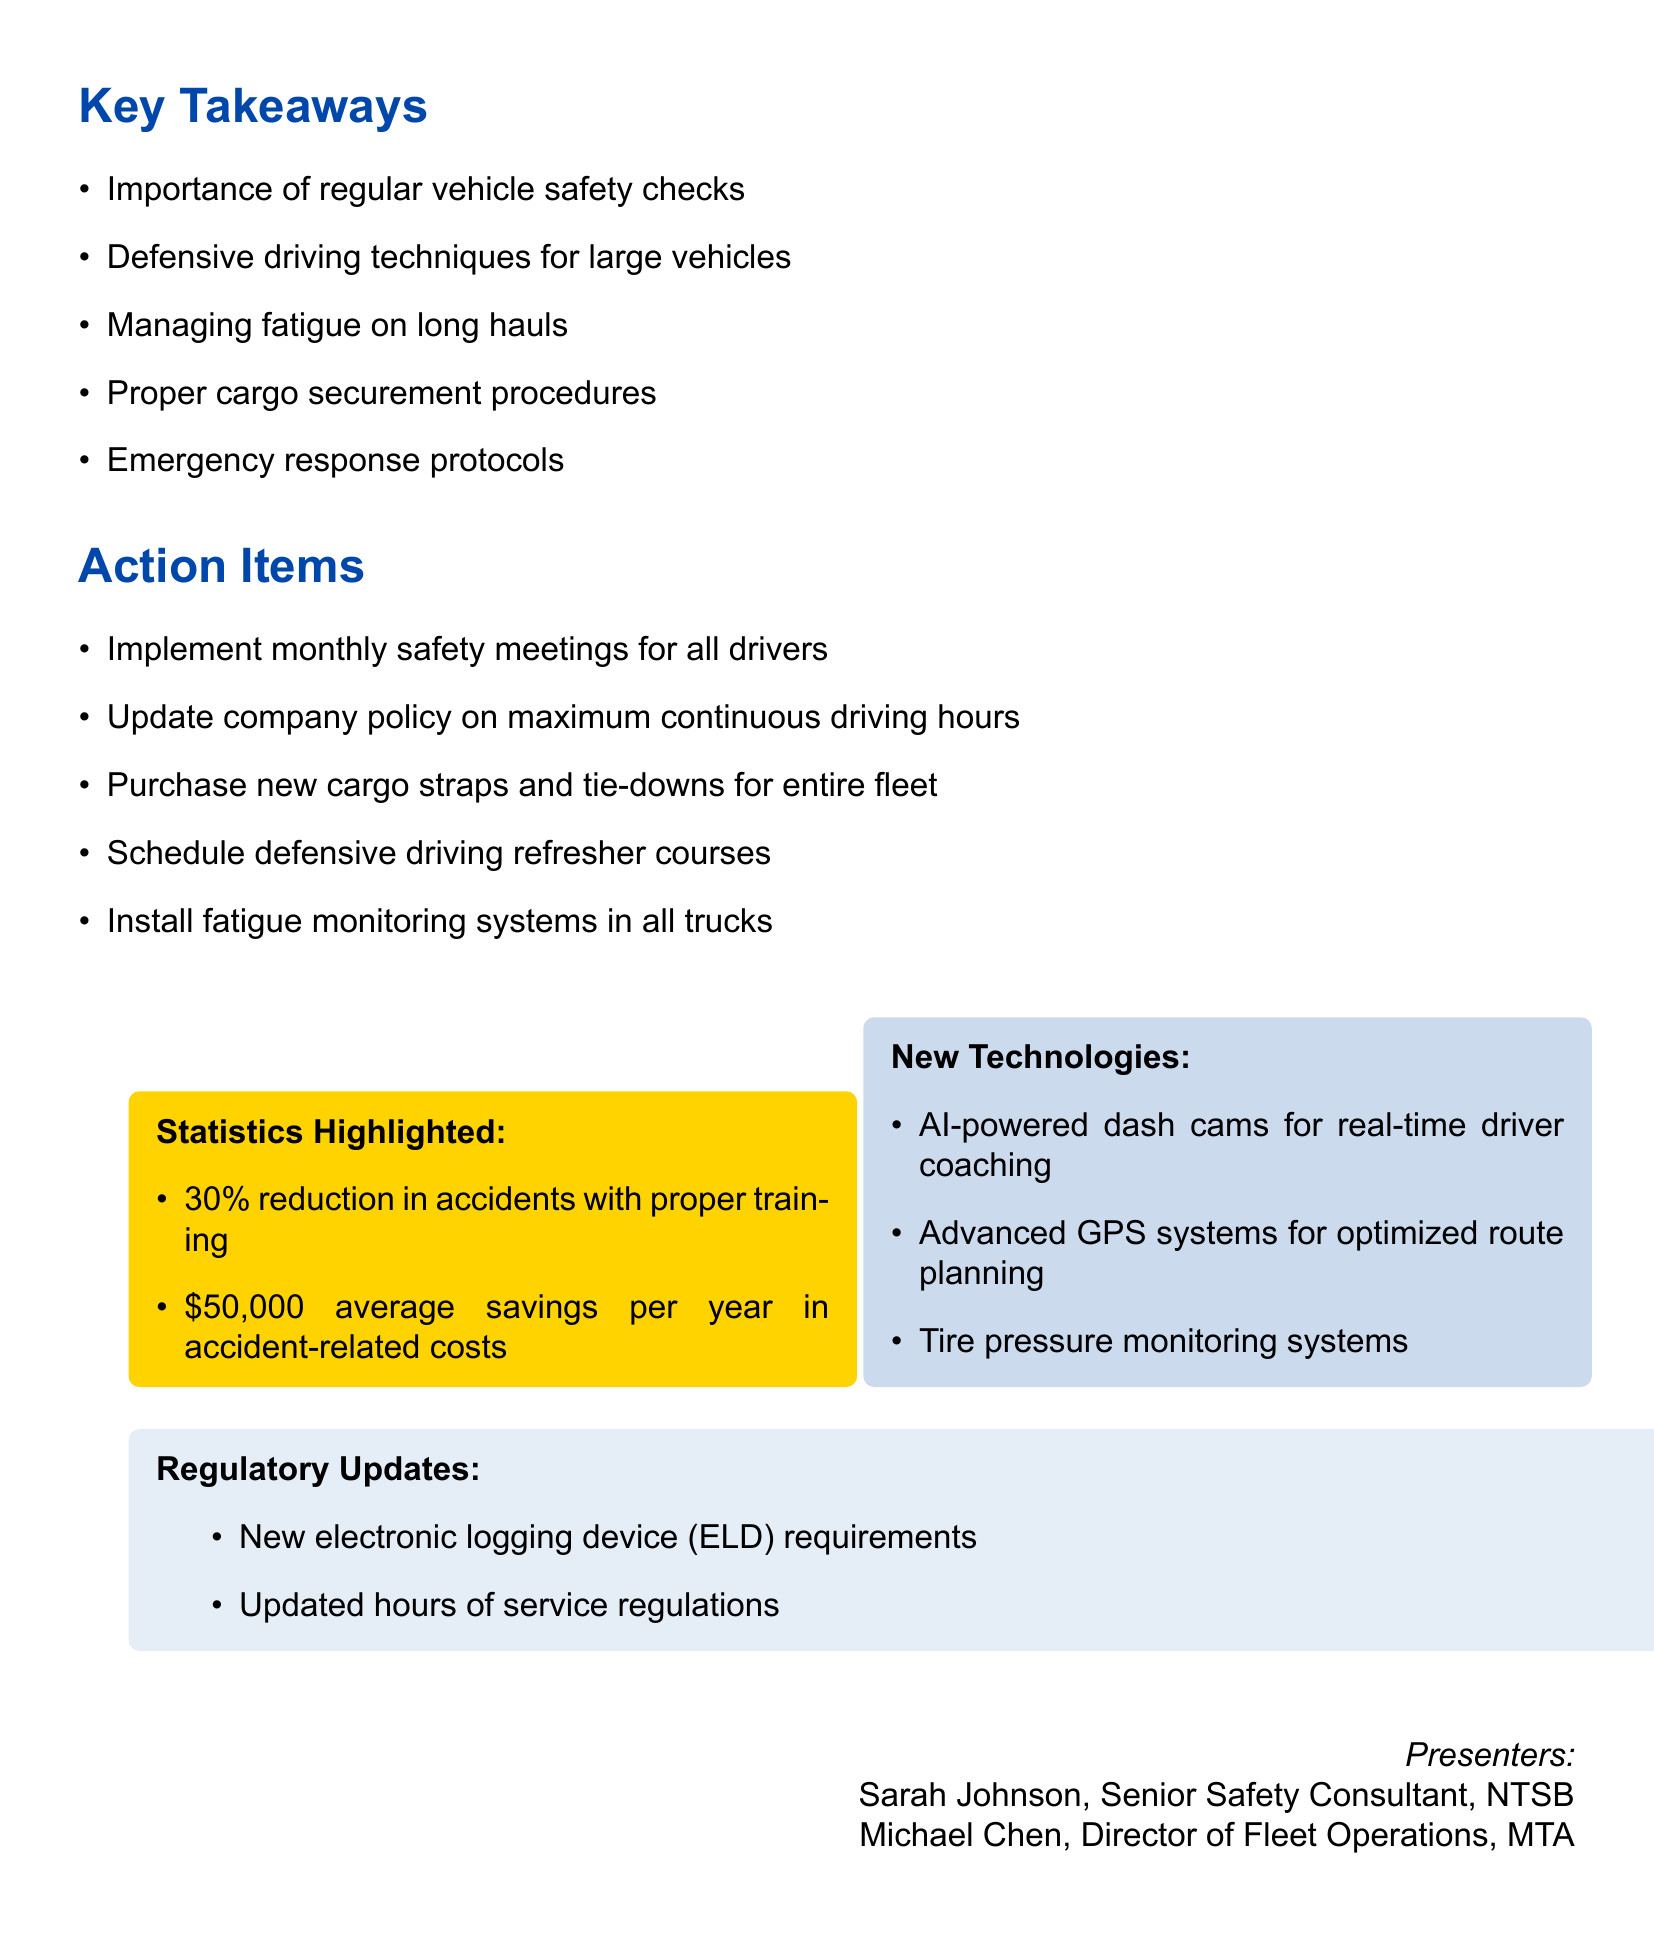What is the title of the seminar? The title of the seminar is clearly stated at the top of the document.
Answer: Advanced Driver Safety Training: Protecting Our Fleet and Community When was the seminar held? The date of the seminar is mentioned prominently in the document.
Answer: May 15, 2023 Who presented at the seminar? The presenters' names and titles are listed in the document.
Answer: Sarah Johnson, Michael Chen What is one key takeaway from the seminar? Key takeaways from the seminar are enumerated in the document.
Answer: Importance of regular vehicle safety checks How much average savings is mentioned in accident-related costs? The statistics highlighted section provides information about cost savings.
Answer: $50,000 average savings per year in accident-related costs What is one of the new technologies discussed? New technologies are listed in the document with specific examples.
Answer: AI-powered dash cams for real-time driver coaching How often should safety meetings be implemented according to the action items? The action items clearly specify the frequency of safety meetings.
Answer: Monthly What percentage reduction in accidents is achievable with proper training? This information is outlined in the statistics highlighted section of the document.
Answer: 30% reduction in accidents with proper training What is one of the regulatory updates mentioned? The regulatory updates section provides specific updates related to regulations.
Answer: New electronic logging device (ELD) requirements 